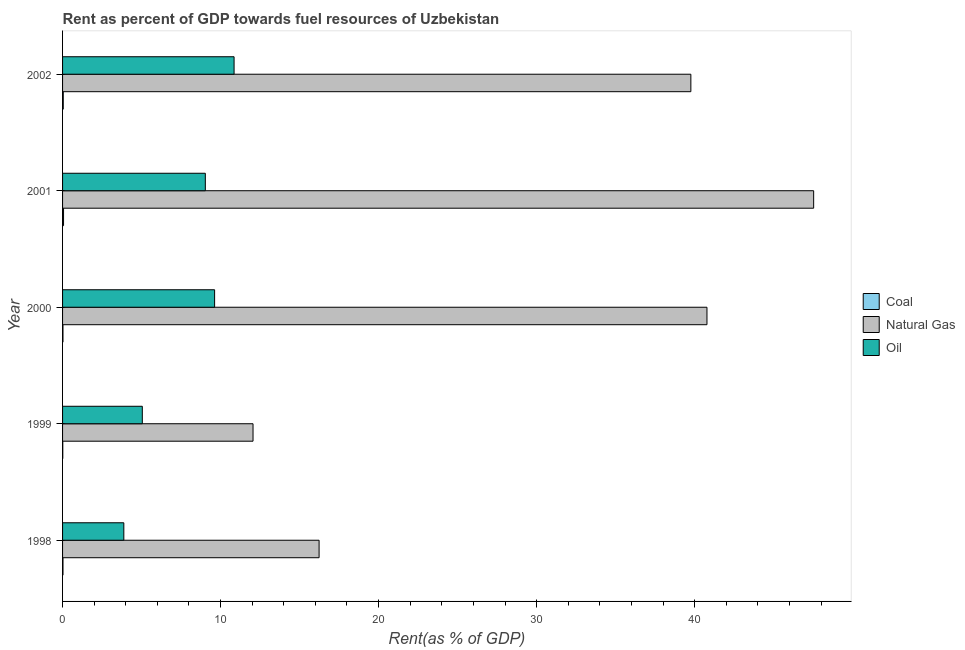How many different coloured bars are there?
Offer a very short reply. 3. How many bars are there on the 1st tick from the bottom?
Make the answer very short. 3. What is the label of the 2nd group of bars from the top?
Make the answer very short. 2001. In how many cases, is the number of bars for a given year not equal to the number of legend labels?
Provide a succinct answer. 0. What is the rent towards natural gas in 2001?
Make the answer very short. 47.53. Across all years, what is the maximum rent towards natural gas?
Provide a succinct answer. 47.53. Across all years, what is the minimum rent towards coal?
Make the answer very short. 0.01. In which year was the rent towards coal maximum?
Your response must be concise. 2001. In which year was the rent towards oil minimum?
Provide a short and direct response. 1998. What is the total rent towards natural gas in the graph?
Keep it short and to the point. 156.37. What is the difference between the rent towards natural gas in 1998 and that in 2002?
Your response must be concise. -23.53. What is the difference between the rent towards coal in 1999 and the rent towards natural gas in 1998?
Your answer should be compact. -16.22. What is the average rent towards oil per year?
Your answer should be compact. 7.69. In the year 2000, what is the difference between the rent towards coal and rent towards natural gas?
Ensure brevity in your answer.  -40.76. What is the ratio of the rent towards natural gas in 2000 to that in 2001?
Give a very brief answer. 0.86. Is the rent towards oil in 2001 less than that in 2002?
Your answer should be very brief. Yes. What is the difference between the highest and the second highest rent towards coal?
Keep it short and to the point. 0.02. What is the difference between the highest and the lowest rent towards oil?
Your response must be concise. 6.98. In how many years, is the rent towards oil greater than the average rent towards oil taken over all years?
Keep it short and to the point. 3. Is the sum of the rent towards oil in 1999 and 2002 greater than the maximum rent towards natural gas across all years?
Ensure brevity in your answer.  No. What does the 3rd bar from the top in 2002 represents?
Give a very brief answer. Coal. What does the 2nd bar from the bottom in 2000 represents?
Your response must be concise. Natural Gas. How many years are there in the graph?
Your response must be concise. 5. What is the difference between two consecutive major ticks on the X-axis?
Ensure brevity in your answer.  10. Does the graph contain any zero values?
Ensure brevity in your answer.  No. Does the graph contain grids?
Keep it short and to the point. No. Where does the legend appear in the graph?
Ensure brevity in your answer.  Center right. How many legend labels are there?
Your answer should be very brief. 3. What is the title of the graph?
Make the answer very short. Rent as percent of GDP towards fuel resources of Uzbekistan. What is the label or title of the X-axis?
Provide a succinct answer. Rent(as % of GDP). What is the Rent(as % of GDP) in Coal in 1998?
Offer a terse response. 0.03. What is the Rent(as % of GDP) of Natural Gas in 1998?
Your response must be concise. 16.23. What is the Rent(as % of GDP) of Oil in 1998?
Your answer should be very brief. 3.88. What is the Rent(as % of GDP) in Coal in 1999?
Offer a very short reply. 0.01. What is the Rent(as % of GDP) of Natural Gas in 1999?
Provide a short and direct response. 12.05. What is the Rent(as % of GDP) of Oil in 1999?
Provide a short and direct response. 5.05. What is the Rent(as % of GDP) of Coal in 2000?
Provide a succinct answer. 0.03. What is the Rent(as % of GDP) of Natural Gas in 2000?
Offer a very short reply. 40.78. What is the Rent(as % of GDP) of Oil in 2000?
Keep it short and to the point. 9.62. What is the Rent(as % of GDP) of Coal in 2001?
Your response must be concise. 0.06. What is the Rent(as % of GDP) of Natural Gas in 2001?
Your answer should be very brief. 47.53. What is the Rent(as % of GDP) in Oil in 2001?
Keep it short and to the point. 9.03. What is the Rent(as % of GDP) in Coal in 2002?
Your response must be concise. 0.04. What is the Rent(as % of GDP) in Natural Gas in 2002?
Give a very brief answer. 39.76. What is the Rent(as % of GDP) in Oil in 2002?
Provide a succinct answer. 10.85. Across all years, what is the maximum Rent(as % of GDP) in Coal?
Keep it short and to the point. 0.06. Across all years, what is the maximum Rent(as % of GDP) of Natural Gas?
Ensure brevity in your answer.  47.53. Across all years, what is the maximum Rent(as % of GDP) of Oil?
Your answer should be very brief. 10.85. Across all years, what is the minimum Rent(as % of GDP) in Coal?
Make the answer very short. 0.01. Across all years, what is the minimum Rent(as % of GDP) of Natural Gas?
Your answer should be compact. 12.05. Across all years, what is the minimum Rent(as % of GDP) in Oil?
Offer a very short reply. 3.88. What is the total Rent(as % of GDP) in Coal in the graph?
Offer a very short reply. 0.17. What is the total Rent(as % of GDP) of Natural Gas in the graph?
Your answer should be compact. 156.37. What is the total Rent(as % of GDP) in Oil in the graph?
Your response must be concise. 38.44. What is the difference between the Rent(as % of GDP) in Coal in 1998 and that in 1999?
Provide a succinct answer. 0.01. What is the difference between the Rent(as % of GDP) in Natural Gas in 1998 and that in 1999?
Give a very brief answer. 4.18. What is the difference between the Rent(as % of GDP) of Oil in 1998 and that in 1999?
Make the answer very short. -1.17. What is the difference between the Rent(as % of GDP) in Coal in 1998 and that in 2000?
Offer a very short reply. 0. What is the difference between the Rent(as % of GDP) of Natural Gas in 1998 and that in 2000?
Offer a very short reply. -24.55. What is the difference between the Rent(as % of GDP) of Oil in 1998 and that in 2000?
Provide a short and direct response. -5.75. What is the difference between the Rent(as % of GDP) of Coal in 1998 and that in 2001?
Your answer should be very brief. -0.03. What is the difference between the Rent(as % of GDP) of Natural Gas in 1998 and that in 2001?
Offer a very short reply. -31.3. What is the difference between the Rent(as % of GDP) in Oil in 1998 and that in 2001?
Keep it short and to the point. -5.16. What is the difference between the Rent(as % of GDP) in Coal in 1998 and that in 2002?
Your answer should be very brief. -0.02. What is the difference between the Rent(as % of GDP) of Natural Gas in 1998 and that in 2002?
Give a very brief answer. -23.53. What is the difference between the Rent(as % of GDP) in Oil in 1998 and that in 2002?
Your answer should be compact. -6.98. What is the difference between the Rent(as % of GDP) of Coal in 1999 and that in 2000?
Offer a terse response. -0.01. What is the difference between the Rent(as % of GDP) in Natural Gas in 1999 and that in 2000?
Give a very brief answer. -28.73. What is the difference between the Rent(as % of GDP) of Oil in 1999 and that in 2000?
Ensure brevity in your answer.  -4.58. What is the difference between the Rent(as % of GDP) of Coal in 1999 and that in 2001?
Provide a succinct answer. -0.05. What is the difference between the Rent(as % of GDP) in Natural Gas in 1999 and that in 2001?
Provide a short and direct response. -35.48. What is the difference between the Rent(as % of GDP) of Oil in 1999 and that in 2001?
Provide a succinct answer. -3.99. What is the difference between the Rent(as % of GDP) of Coal in 1999 and that in 2002?
Offer a very short reply. -0.03. What is the difference between the Rent(as % of GDP) of Natural Gas in 1999 and that in 2002?
Provide a succinct answer. -27.71. What is the difference between the Rent(as % of GDP) in Oil in 1999 and that in 2002?
Make the answer very short. -5.81. What is the difference between the Rent(as % of GDP) of Coal in 2000 and that in 2001?
Your answer should be compact. -0.04. What is the difference between the Rent(as % of GDP) in Natural Gas in 2000 and that in 2001?
Keep it short and to the point. -6.75. What is the difference between the Rent(as % of GDP) in Oil in 2000 and that in 2001?
Your response must be concise. 0.59. What is the difference between the Rent(as % of GDP) of Coal in 2000 and that in 2002?
Ensure brevity in your answer.  -0.02. What is the difference between the Rent(as % of GDP) in Natural Gas in 2000 and that in 2002?
Offer a terse response. 1.02. What is the difference between the Rent(as % of GDP) in Oil in 2000 and that in 2002?
Make the answer very short. -1.23. What is the difference between the Rent(as % of GDP) in Coal in 2001 and that in 2002?
Keep it short and to the point. 0.02. What is the difference between the Rent(as % of GDP) of Natural Gas in 2001 and that in 2002?
Your answer should be very brief. 7.77. What is the difference between the Rent(as % of GDP) of Oil in 2001 and that in 2002?
Offer a terse response. -1.82. What is the difference between the Rent(as % of GDP) in Coal in 1998 and the Rent(as % of GDP) in Natural Gas in 1999?
Ensure brevity in your answer.  -12.03. What is the difference between the Rent(as % of GDP) of Coal in 1998 and the Rent(as % of GDP) of Oil in 1999?
Provide a succinct answer. -5.02. What is the difference between the Rent(as % of GDP) of Natural Gas in 1998 and the Rent(as % of GDP) of Oil in 1999?
Your response must be concise. 11.19. What is the difference between the Rent(as % of GDP) in Coal in 1998 and the Rent(as % of GDP) in Natural Gas in 2000?
Your answer should be compact. -40.76. What is the difference between the Rent(as % of GDP) in Coal in 1998 and the Rent(as % of GDP) in Oil in 2000?
Your answer should be very brief. -9.6. What is the difference between the Rent(as % of GDP) in Natural Gas in 1998 and the Rent(as % of GDP) in Oil in 2000?
Make the answer very short. 6.61. What is the difference between the Rent(as % of GDP) of Coal in 1998 and the Rent(as % of GDP) of Natural Gas in 2001?
Your answer should be very brief. -47.51. What is the difference between the Rent(as % of GDP) in Coal in 1998 and the Rent(as % of GDP) in Oil in 2001?
Your answer should be very brief. -9.01. What is the difference between the Rent(as % of GDP) in Natural Gas in 1998 and the Rent(as % of GDP) in Oil in 2001?
Ensure brevity in your answer.  7.2. What is the difference between the Rent(as % of GDP) of Coal in 1998 and the Rent(as % of GDP) of Natural Gas in 2002?
Give a very brief answer. -39.74. What is the difference between the Rent(as % of GDP) of Coal in 1998 and the Rent(as % of GDP) of Oil in 2002?
Ensure brevity in your answer.  -10.83. What is the difference between the Rent(as % of GDP) of Natural Gas in 1998 and the Rent(as % of GDP) of Oil in 2002?
Offer a very short reply. 5.38. What is the difference between the Rent(as % of GDP) in Coal in 1999 and the Rent(as % of GDP) in Natural Gas in 2000?
Give a very brief answer. -40.77. What is the difference between the Rent(as % of GDP) in Coal in 1999 and the Rent(as % of GDP) in Oil in 2000?
Ensure brevity in your answer.  -9.61. What is the difference between the Rent(as % of GDP) of Natural Gas in 1999 and the Rent(as % of GDP) of Oil in 2000?
Offer a very short reply. 2.43. What is the difference between the Rent(as % of GDP) in Coal in 1999 and the Rent(as % of GDP) in Natural Gas in 2001?
Offer a terse response. -47.52. What is the difference between the Rent(as % of GDP) in Coal in 1999 and the Rent(as % of GDP) in Oil in 2001?
Give a very brief answer. -9.02. What is the difference between the Rent(as % of GDP) of Natural Gas in 1999 and the Rent(as % of GDP) of Oil in 2001?
Ensure brevity in your answer.  3.02. What is the difference between the Rent(as % of GDP) of Coal in 1999 and the Rent(as % of GDP) of Natural Gas in 2002?
Your response must be concise. -39.75. What is the difference between the Rent(as % of GDP) of Coal in 1999 and the Rent(as % of GDP) of Oil in 2002?
Your answer should be very brief. -10.84. What is the difference between the Rent(as % of GDP) in Natural Gas in 1999 and the Rent(as % of GDP) in Oil in 2002?
Provide a succinct answer. 1.2. What is the difference between the Rent(as % of GDP) in Coal in 2000 and the Rent(as % of GDP) in Natural Gas in 2001?
Provide a succinct answer. -47.51. What is the difference between the Rent(as % of GDP) in Coal in 2000 and the Rent(as % of GDP) in Oil in 2001?
Your response must be concise. -9.01. What is the difference between the Rent(as % of GDP) in Natural Gas in 2000 and the Rent(as % of GDP) in Oil in 2001?
Give a very brief answer. 31.75. What is the difference between the Rent(as % of GDP) in Coal in 2000 and the Rent(as % of GDP) in Natural Gas in 2002?
Your answer should be compact. -39.74. What is the difference between the Rent(as % of GDP) in Coal in 2000 and the Rent(as % of GDP) in Oil in 2002?
Provide a short and direct response. -10.83. What is the difference between the Rent(as % of GDP) of Natural Gas in 2000 and the Rent(as % of GDP) of Oil in 2002?
Offer a terse response. 29.93. What is the difference between the Rent(as % of GDP) of Coal in 2001 and the Rent(as % of GDP) of Natural Gas in 2002?
Offer a terse response. -39.7. What is the difference between the Rent(as % of GDP) in Coal in 2001 and the Rent(as % of GDP) in Oil in 2002?
Give a very brief answer. -10.79. What is the difference between the Rent(as % of GDP) in Natural Gas in 2001 and the Rent(as % of GDP) in Oil in 2002?
Make the answer very short. 36.68. What is the average Rent(as % of GDP) of Coal per year?
Your answer should be compact. 0.03. What is the average Rent(as % of GDP) in Natural Gas per year?
Provide a succinct answer. 31.27. What is the average Rent(as % of GDP) of Oil per year?
Keep it short and to the point. 7.69. In the year 1998, what is the difference between the Rent(as % of GDP) of Coal and Rent(as % of GDP) of Natural Gas?
Ensure brevity in your answer.  -16.21. In the year 1998, what is the difference between the Rent(as % of GDP) in Coal and Rent(as % of GDP) in Oil?
Make the answer very short. -3.85. In the year 1998, what is the difference between the Rent(as % of GDP) in Natural Gas and Rent(as % of GDP) in Oil?
Keep it short and to the point. 12.36. In the year 1999, what is the difference between the Rent(as % of GDP) of Coal and Rent(as % of GDP) of Natural Gas?
Make the answer very short. -12.04. In the year 1999, what is the difference between the Rent(as % of GDP) of Coal and Rent(as % of GDP) of Oil?
Provide a short and direct response. -5.03. In the year 1999, what is the difference between the Rent(as % of GDP) in Natural Gas and Rent(as % of GDP) in Oil?
Ensure brevity in your answer.  7.01. In the year 2000, what is the difference between the Rent(as % of GDP) of Coal and Rent(as % of GDP) of Natural Gas?
Keep it short and to the point. -40.76. In the year 2000, what is the difference between the Rent(as % of GDP) in Coal and Rent(as % of GDP) in Oil?
Your answer should be very brief. -9.6. In the year 2000, what is the difference between the Rent(as % of GDP) in Natural Gas and Rent(as % of GDP) in Oil?
Provide a succinct answer. 31.16. In the year 2001, what is the difference between the Rent(as % of GDP) of Coal and Rent(as % of GDP) of Natural Gas?
Your answer should be compact. -47.47. In the year 2001, what is the difference between the Rent(as % of GDP) in Coal and Rent(as % of GDP) in Oil?
Give a very brief answer. -8.97. In the year 2001, what is the difference between the Rent(as % of GDP) of Natural Gas and Rent(as % of GDP) of Oil?
Make the answer very short. 38.5. In the year 2002, what is the difference between the Rent(as % of GDP) of Coal and Rent(as % of GDP) of Natural Gas?
Make the answer very short. -39.72. In the year 2002, what is the difference between the Rent(as % of GDP) in Coal and Rent(as % of GDP) in Oil?
Give a very brief answer. -10.81. In the year 2002, what is the difference between the Rent(as % of GDP) in Natural Gas and Rent(as % of GDP) in Oil?
Give a very brief answer. 28.91. What is the ratio of the Rent(as % of GDP) in Coal in 1998 to that in 1999?
Offer a very short reply. 1.92. What is the ratio of the Rent(as % of GDP) of Natural Gas in 1998 to that in 1999?
Provide a succinct answer. 1.35. What is the ratio of the Rent(as % of GDP) of Oil in 1998 to that in 1999?
Ensure brevity in your answer.  0.77. What is the ratio of the Rent(as % of GDP) of Coal in 1998 to that in 2000?
Your response must be concise. 1.05. What is the ratio of the Rent(as % of GDP) of Natural Gas in 1998 to that in 2000?
Make the answer very short. 0.4. What is the ratio of the Rent(as % of GDP) in Oil in 1998 to that in 2000?
Offer a terse response. 0.4. What is the ratio of the Rent(as % of GDP) in Coal in 1998 to that in 2001?
Ensure brevity in your answer.  0.43. What is the ratio of the Rent(as % of GDP) of Natural Gas in 1998 to that in 2001?
Offer a very short reply. 0.34. What is the ratio of the Rent(as % of GDP) of Oil in 1998 to that in 2001?
Give a very brief answer. 0.43. What is the ratio of the Rent(as % of GDP) in Coal in 1998 to that in 2002?
Your answer should be very brief. 0.6. What is the ratio of the Rent(as % of GDP) of Natural Gas in 1998 to that in 2002?
Offer a very short reply. 0.41. What is the ratio of the Rent(as % of GDP) in Oil in 1998 to that in 2002?
Offer a terse response. 0.36. What is the ratio of the Rent(as % of GDP) in Coal in 1999 to that in 2000?
Offer a very short reply. 0.55. What is the ratio of the Rent(as % of GDP) in Natural Gas in 1999 to that in 2000?
Ensure brevity in your answer.  0.3. What is the ratio of the Rent(as % of GDP) in Oil in 1999 to that in 2000?
Make the answer very short. 0.52. What is the ratio of the Rent(as % of GDP) of Coal in 1999 to that in 2001?
Offer a very short reply. 0.23. What is the ratio of the Rent(as % of GDP) of Natural Gas in 1999 to that in 2001?
Your answer should be compact. 0.25. What is the ratio of the Rent(as % of GDP) of Oil in 1999 to that in 2001?
Make the answer very short. 0.56. What is the ratio of the Rent(as % of GDP) of Coal in 1999 to that in 2002?
Offer a very short reply. 0.31. What is the ratio of the Rent(as % of GDP) of Natural Gas in 1999 to that in 2002?
Offer a terse response. 0.3. What is the ratio of the Rent(as % of GDP) in Oil in 1999 to that in 2002?
Make the answer very short. 0.46. What is the ratio of the Rent(as % of GDP) in Coal in 2000 to that in 2001?
Offer a terse response. 0.41. What is the ratio of the Rent(as % of GDP) of Natural Gas in 2000 to that in 2001?
Your answer should be compact. 0.86. What is the ratio of the Rent(as % of GDP) in Oil in 2000 to that in 2001?
Ensure brevity in your answer.  1.06. What is the ratio of the Rent(as % of GDP) of Coal in 2000 to that in 2002?
Offer a terse response. 0.57. What is the ratio of the Rent(as % of GDP) of Natural Gas in 2000 to that in 2002?
Provide a succinct answer. 1.03. What is the ratio of the Rent(as % of GDP) of Oil in 2000 to that in 2002?
Your response must be concise. 0.89. What is the ratio of the Rent(as % of GDP) of Coal in 2001 to that in 2002?
Keep it short and to the point. 1.39. What is the ratio of the Rent(as % of GDP) of Natural Gas in 2001 to that in 2002?
Keep it short and to the point. 1.2. What is the ratio of the Rent(as % of GDP) of Oil in 2001 to that in 2002?
Ensure brevity in your answer.  0.83. What is the difference between the highest and the second highest Rent(as % of GDP) of Coal?
Your response must be concise. 0.02. What is the difference between the highest and the second highest Rent(as % of GDP) in Natural Gas?
Offer a very short reply. 6.75. What is the difference between the highest and the second highest Rent(as % of GDP) in Oil?
Provide a succinct answer. 1.23. What is the difference between the highest and the lowest Rent(as % of GDP) of Coal?
Provide a short and direct response. 0.05. What is the difference between the highest and the lowest Rent(as % of GDP) of Natural Gas?
Make the answer very short. 35.48. What is the difference between the highest and the lowest Rent(as % of GDP) in Oil?
Make the answer very short. 6.98. 